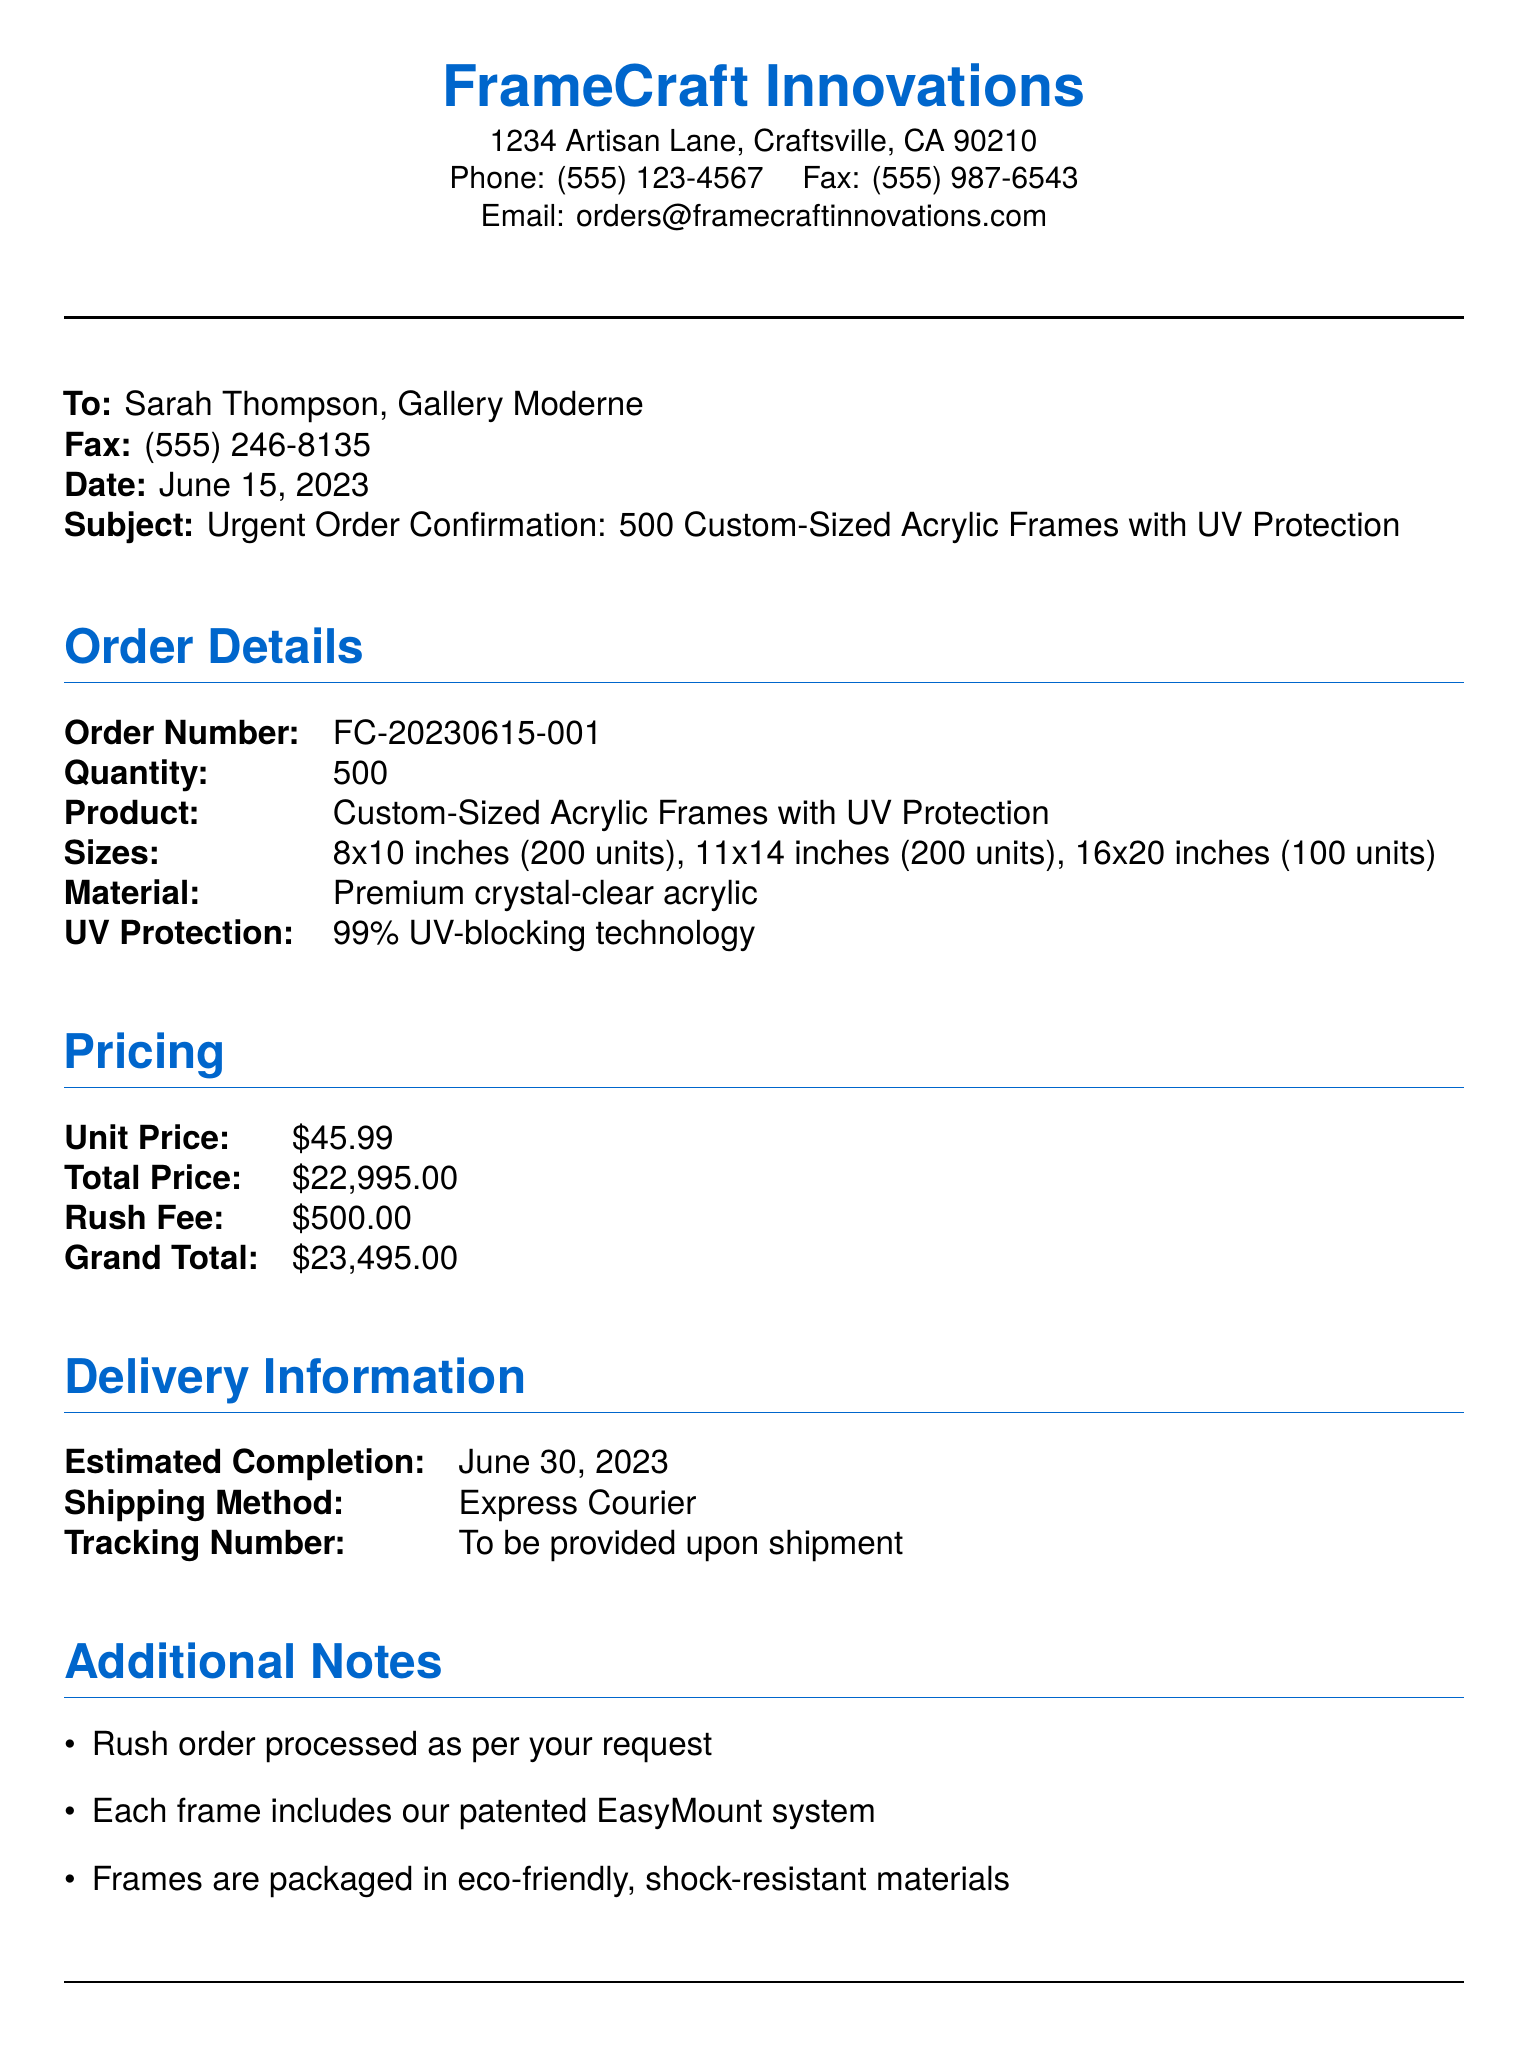What is the order number? The order number is explicitly stated in the order details section of the document.
Answer: FC-20230615-001 What is the total price for the order? The total price is provided in the pricing section of the document and represents the overall cost before any fees.
Answer: $22,995.00 How many units of 8x10 frames are included in the order? The document specifies the quantity of each size of frame, and this is one of the sizes listed.
Answer: 200 units When is the estimated completion date? The estimated completion date is clearly stated in the delivery information section of the document.
Answer: June 30, 2023 What is the rush fee charged for this order? A specific fee associated with processing the order urgently is listed in the pricing section.
Answer: $500.00 What sizes of frames are being ordered? Sizes are listed in the order details section, detailing the specific dimensions included.
Answer: 8x10 inches, 11x14 inches, 16x20 inches Who is the sales manager at FrameCraft Innovations? The name of the individual in this position is provided at the end of the document.
Answer: Michael Chen What is the shipping method for the order? The shipping method is indicated in the delivery information section and informs how the order will be sent.
Answer: Express Courier What is included with each frame? Additional information about the frames is found in the notes section, detailing special features.
Answer: EasyMount system 